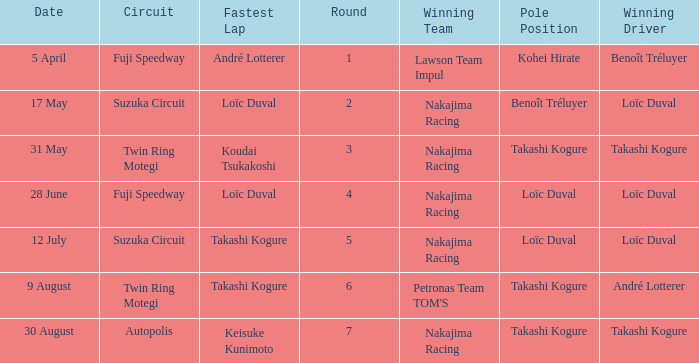How many drivers drove on Suzuka Circuit where Loïc Duval took pole position? 1.0. 